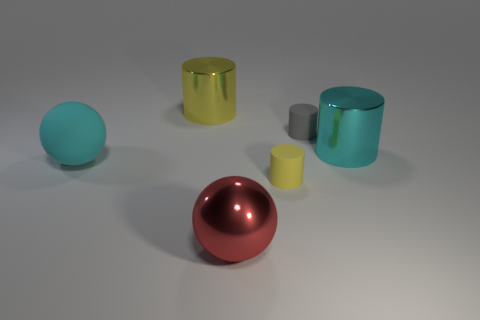What number of spheres are either red things or big cyan objects?
Keep it short and to the point. 2. What is the shape of the big cyan thing that is on the right side of the rubber ball?
Ensure brevity in your answer.  Cylinder. What is the color of the sphere to the right of the cylinder that is on the left side of the yellow thing in front of the cyan matte sphere?
Give a very brief answer. Red. Does the large red object have the same material as the cyan ball?
Make the answer very short. No. What number of blue things are either small objects or shiny balls?
Keep it short and to the point. 0. There is a big red ball; what number of yellow metallic cylinders are to the right of it?
Your response must be concise. 0. Is the number of big yellow metallic cylinders greater than the number of large metal cylinders?
Your response must be concise. No. What shape is the cyan thing on the right side of the rubber object that is behind the large cyan ball?
Give a very brief answer. Cylinder. Is the number of rubber cylinders in front of the cyan metallic object greater than the number of big gray metallic objects?
Give a very brief answer. Yes. How many big objects are to the right of the big shiny thing that is in front of the cyan metallic object?
Provide a short and direct response. 1. 